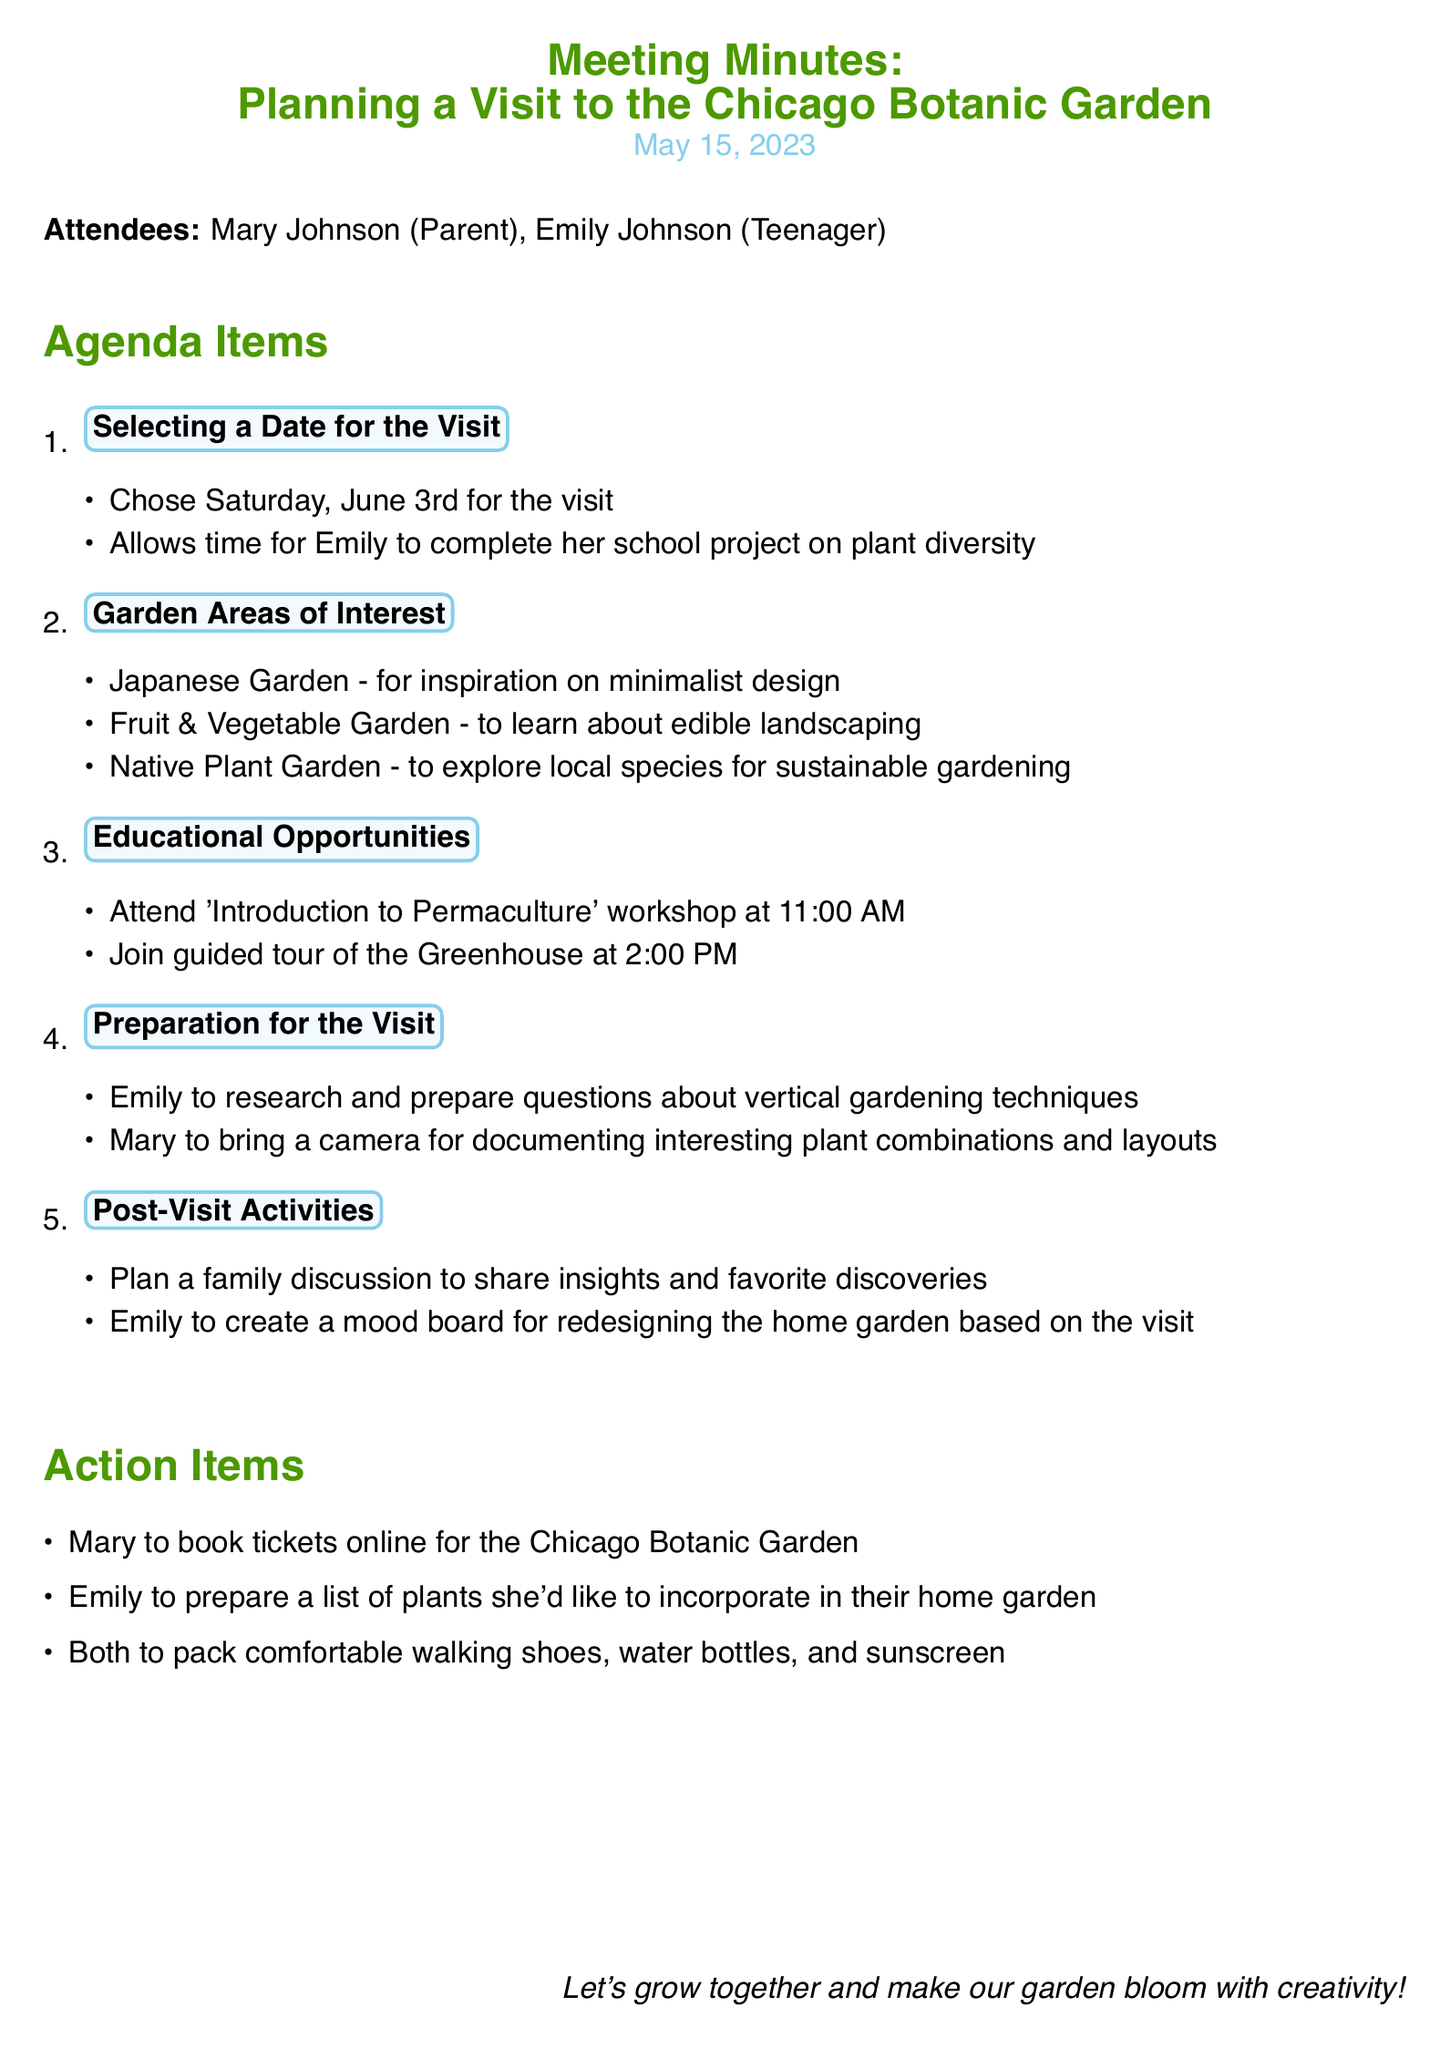what is the date of the visit? The date of the visit is mentioned in the meeting minutes as Saturday, June 3rd.
Answer: Saturday, June 3rd who is the teenager attending the meeting? The names of the attendees are listed, and Emily Johnson is identified as the teenager.
Answer: Emily Johnson what workshop is scheduled for 11:00 AM? The meeting minutes include an educational opportunity for a workshop at that time, "Introduction to Permaculture".
Answer: Introduction to Permaculture which garden area is mentioned for learning about edible landscaping? The discussion points list the Fruit & Vegetable Garden specifically for learning about edible landscaping.
Answer: Fruit & Vegetable Garden what will Emily create after the visit? The meeting minutes mention that Emily will create a mood board based on their discoveries from the visit.
Answer: mood board how many attendees were present at the meeting? The meeting minutes describe two attendees, Mary Johnson and Emily Johnson.
Answer: 2 what is one item Mary is responsible for before the visit? The action items include that Mary will book tickets online for the garden.
Answer: book tickets what will both Mary and Emily pack for the visit? The action items specify packing comfortable walking shoes, water bottles, and sunscreen.
Answer: comfortable walking shoes, water bottles, and sunscreen 